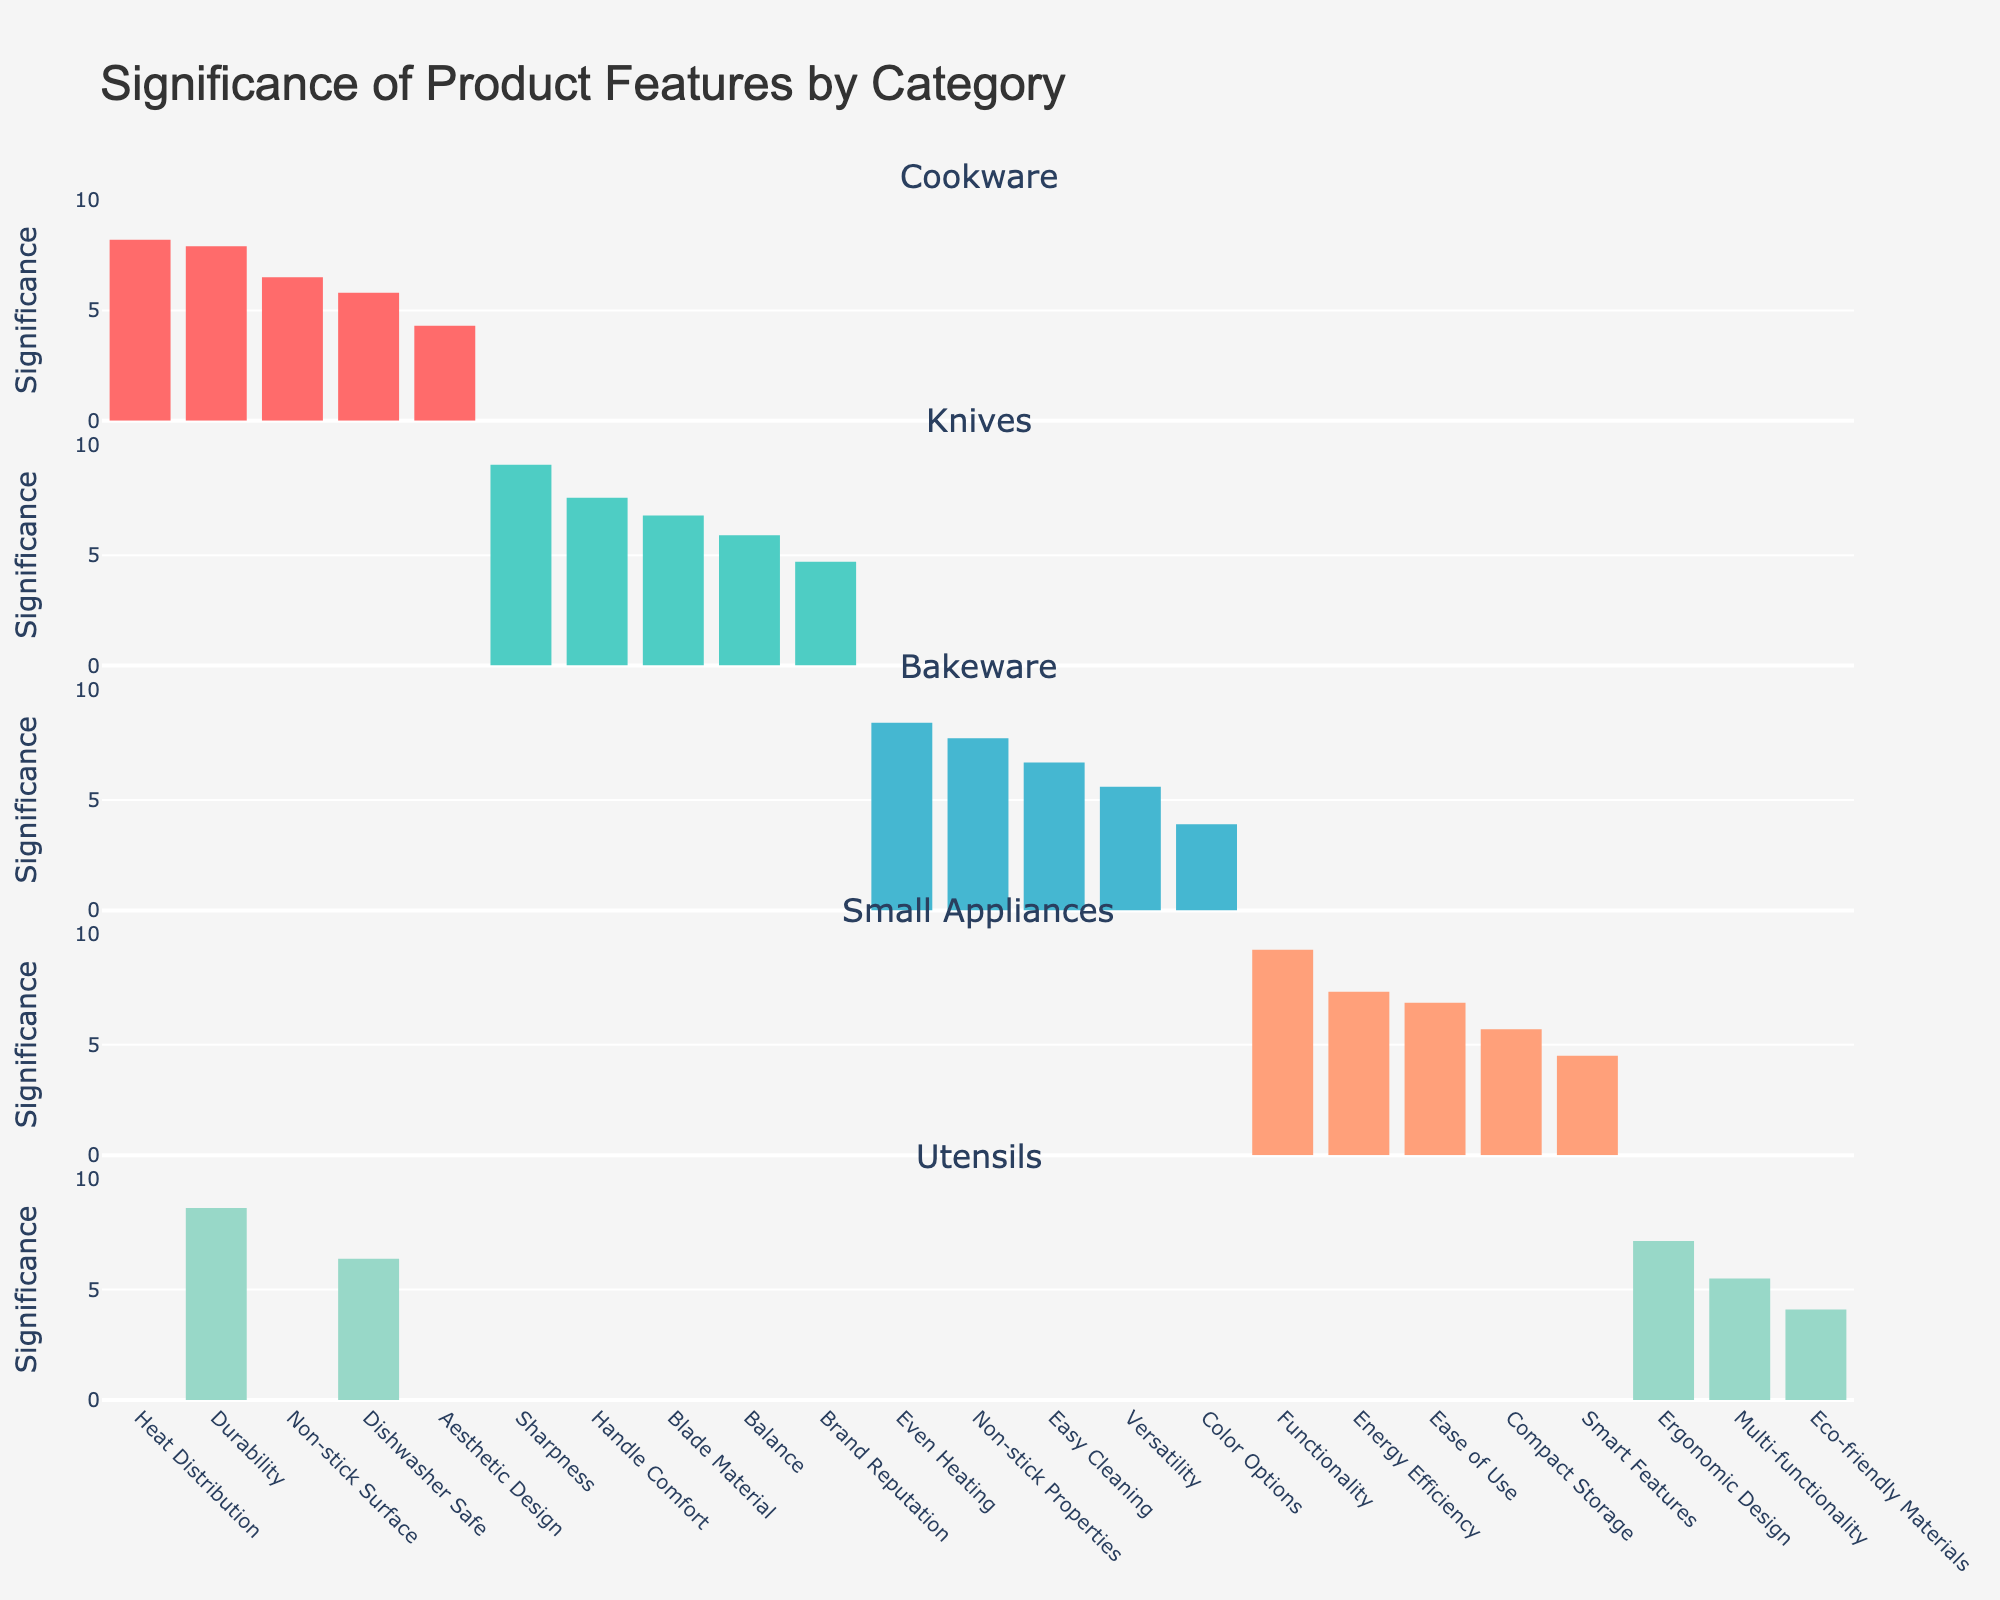What's the most significant feature for Cookware? Look at the Cookware category and find the feature with the highest bar. The "Heat Distribution" feature has the highest significance score of 8.2.
Answer: Heat Distribution Which category has the feature with the highest overall significance across all categories? Look at the bar with the highest significance across all categories. The highest significance score is 9.3 for "Functionality" in the Small Appliances category.
Answer: Small Appliances In the Knives category, how much more significant is Sharpness compared to Brand Reputation? Find the significance scores for "Sharpness" (9.1) and "Brand Reputation" (4.7). Subtract the lower score from the higher one: 9.1 - 4.7 = 4.4.
Answer: 4.4 What's the average significance of the features in the Bakeware category? Add up the significance scores in Bakeware (8.5, 7.8, 6.7, 5.6, 3.9) and divide by the number of features: (8.5 + 7.8 + 6.7 + 5.6 + 3.9) / 5 = 6.5.
Answer: 6.5 Which category has the smallest range between the highest and lowest significance scores? Calculate the range for each category:
- Cookware: 8.2 - 4.3 = 3.9
- Knives: 9.1 - 4.7 = 4.4
- Bakeware: 8.5 - 3.9 = 4.6
- Small Appliances: 9.3 - 4.5 = 4.8
- Utensils: 8.7 - 4.1 = 4.6
The Cookware category has the smallest range of 3.9.
Answer: Cookware How many features in the Utensils category have a significance score greater than 6? Count the bars in the Utensils category with significance scores greater than 6: "Durability" (8.7) and "Ergonomic Design" (7.2). There are 2 features.
Answer: 2 In which category is the "Non-stick" feature, and what is its significance score? Look for the "Non-stick" feature across categories. It appears in both Cookware ("Non-stick Surface" 6.5) and Bakeware ("Non-stick Properties" 7.8). The corresponding significance scores are 6.5 and 7.8.
Answer: Cookware: 6.5, Bakeware: 7.8 What is the total significance score for all features in Small Appliances? Add the significance scores for Small Appliances (9.3, 7.4, 6.9, 5.7, 4.5): 9.3 + 7.4 + 6.9 + 5.7 + 4.5 = 33.8.
Answer: 33.8 